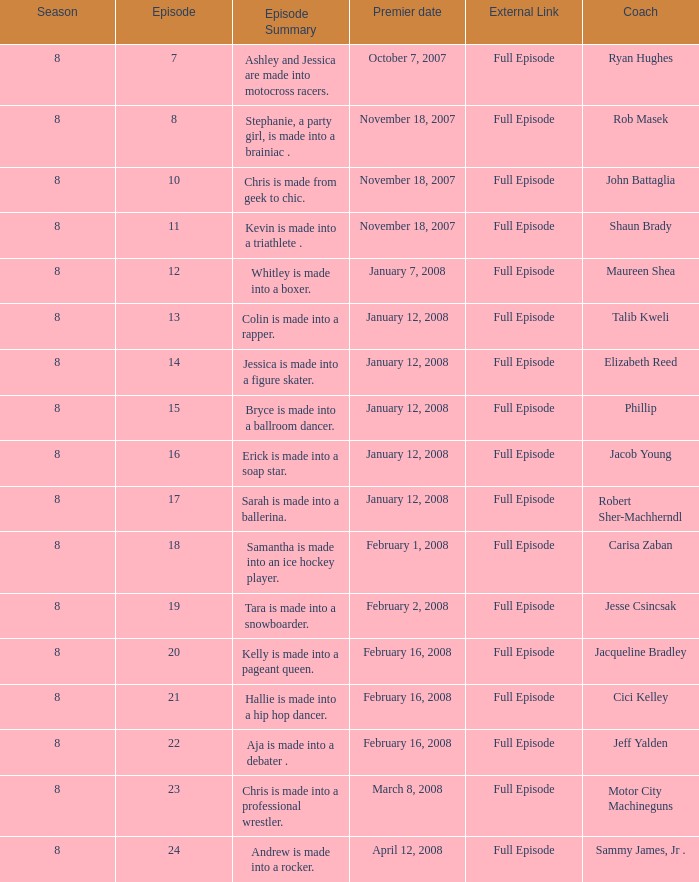Which Maximum episode premiered March 8, 2008? 23.0. 